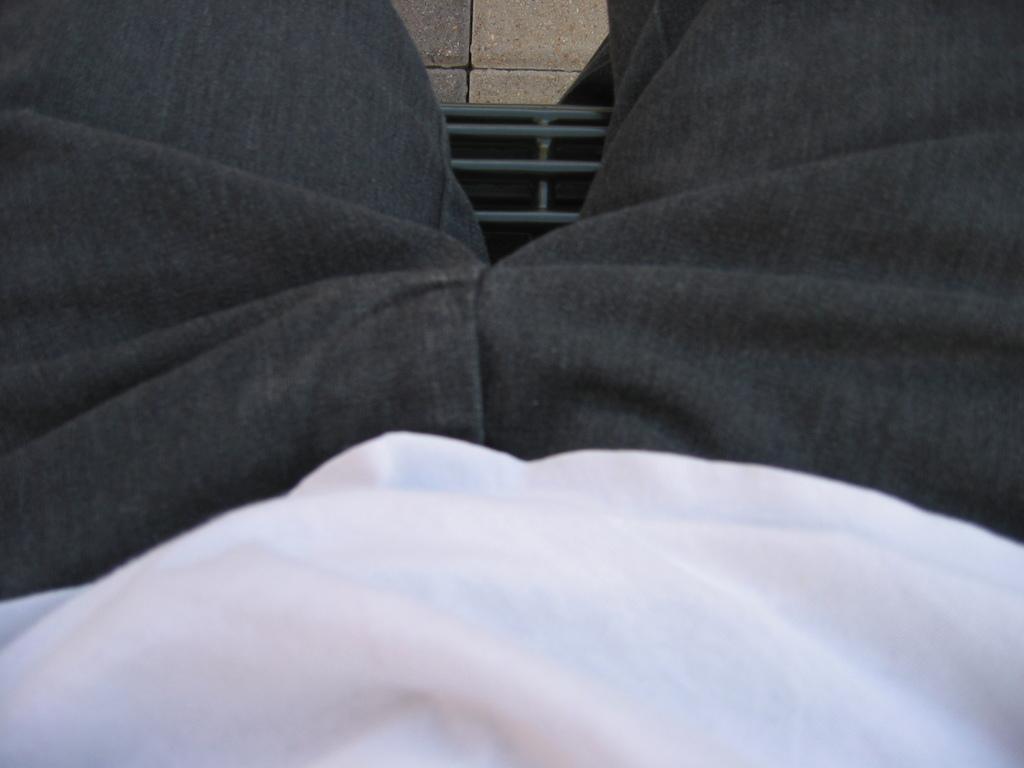Please provide a concise description of this image. There is a person sitting and we can see floor. 